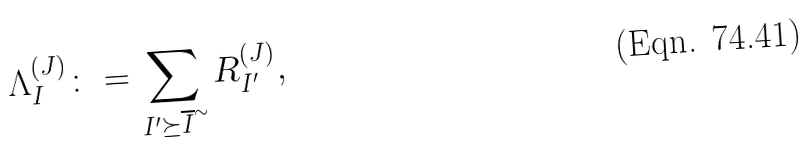<formula> <loc_0><loc_0><loc_500><loc_500>\Lambda _ { I } ^ { ( J ) } \colon = \sum _ { I ^ { \prime } \succeq { \overline { I } } ^ { \sim } } R _ { I ^ { \prime } } ^ { ( J ) } ,</formula> 